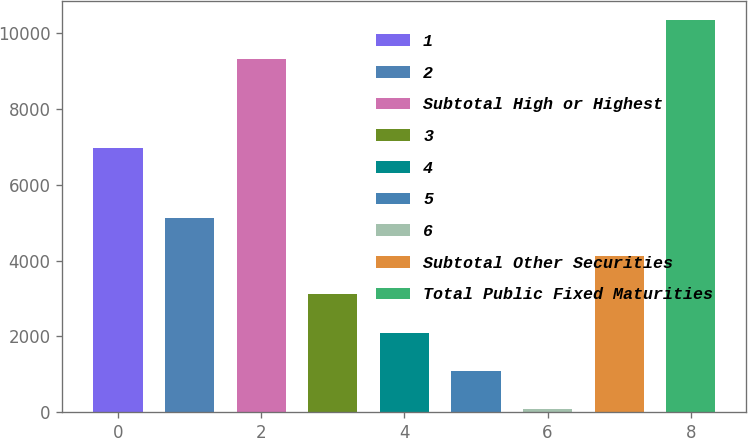Convert chart. <chart><loc_0><loc_0><loc_500><loc_500><bar_chart><fcel>1<fcel>2<fcel>Subtotal High or Highest<fcel>3<fcel>4<fcel>5<fcel>6<fcel>Subtotal Other Securities<fcel>Total Public Fixed Maturities<nl><fcel>6986<fcel>5137<fcel>9335<fcel>3112.6<fcel>2100.4<fcel>1088.2<fcel>76<fcel>4124.8<fcel>10347.2<nl></chart> 